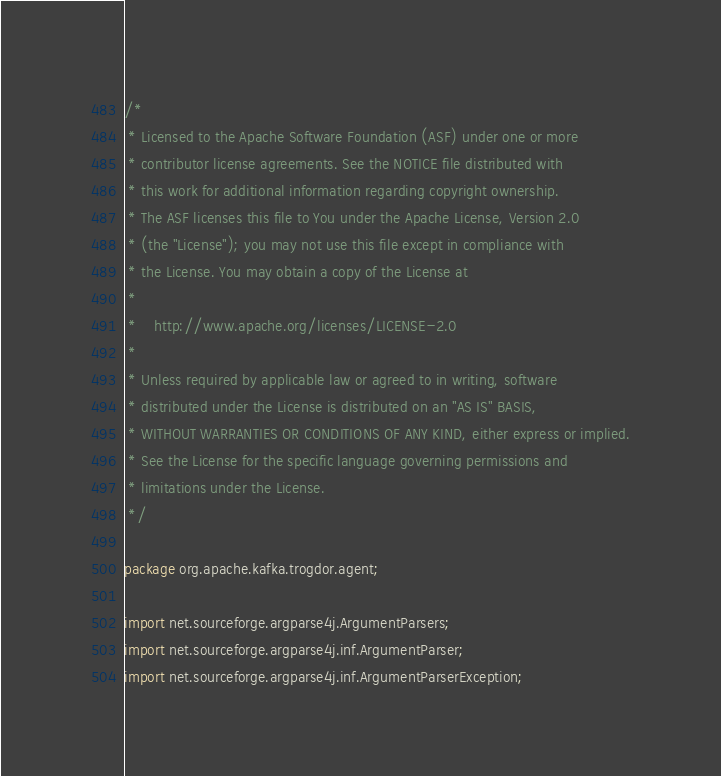<code> <loc_0><loc_0><loc_500><loc_500><_Java_>/*
 * Licensed to the Apache Software Foundation (ASF) under one or more
 * contributor license agreements. See the NOTICE file distributed with
 * this work for additional information regarding copyright ownership.
 * The ASF licenses this file to You under the Apache License, Version 2.0
 * (the "License"); you may not use this file except in compliance with
 * the License. You may obtain a copy of the License at
 *
 *    http://www.apache.org/licenses/LICENSE-2.0
 *
 * Unless required by applicable law or agreed to in writing, software
 * distributed under the License is distributed on an "AS IS" BASIS,
 * WITHOUT WARRANTIES OR CONDITIONS OF ANY KIND, either express or implied.
 * See the License for the specific language governing permissions and
 * limitations under the License.
 */

package org.apache.kafka.trogdor.agent;

import net.sourceforge.argparse4j.ArgumentParsers;
import net.sourceforge.argparse4j.inf.ArgumentParser;
import net.sourceforge.argparse4j.inf.ArgumentParserException;</code> 